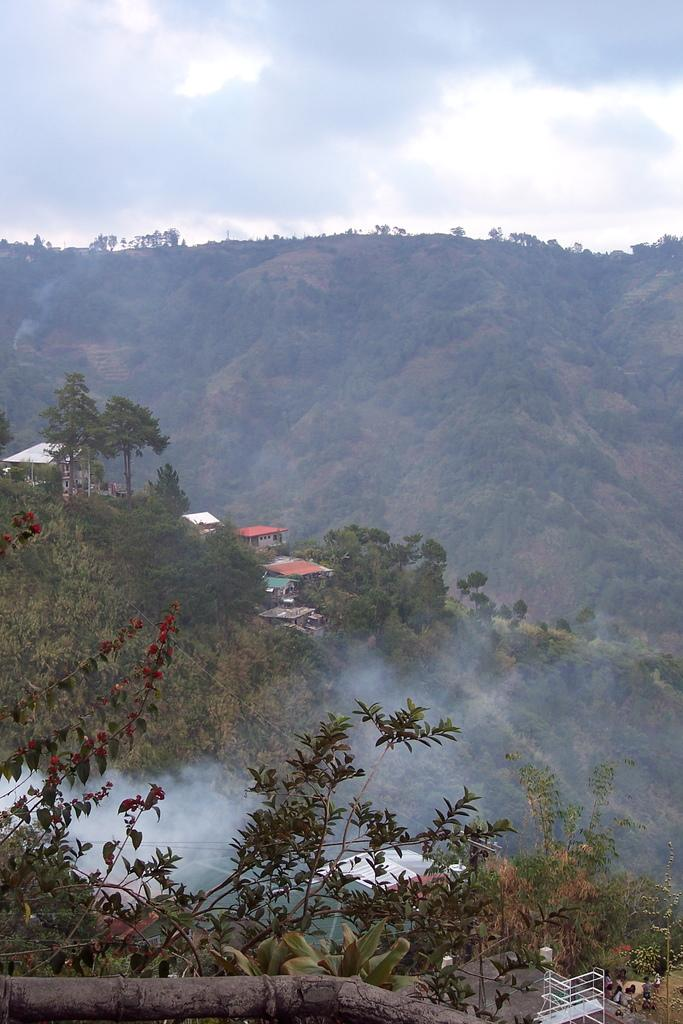What type of structures can be seen on the hills in the image? There are houses on the hills in the image. What can be observed near the hills in the image? There is smoke near the hills in the image. What is visible at the top of the image? The sky is visible at the top of the image. What type of vegetation is present on the hills in the image? There are trees on the hills in the image. How many nails are used to hold the judge's gavel in the image? There is no judge or gavel present in the image; it features houses, hills, smoke, trees, and the sky. What is the way the trees are walking on the hills in the image? Trees do not walk; they are stationary plants. 